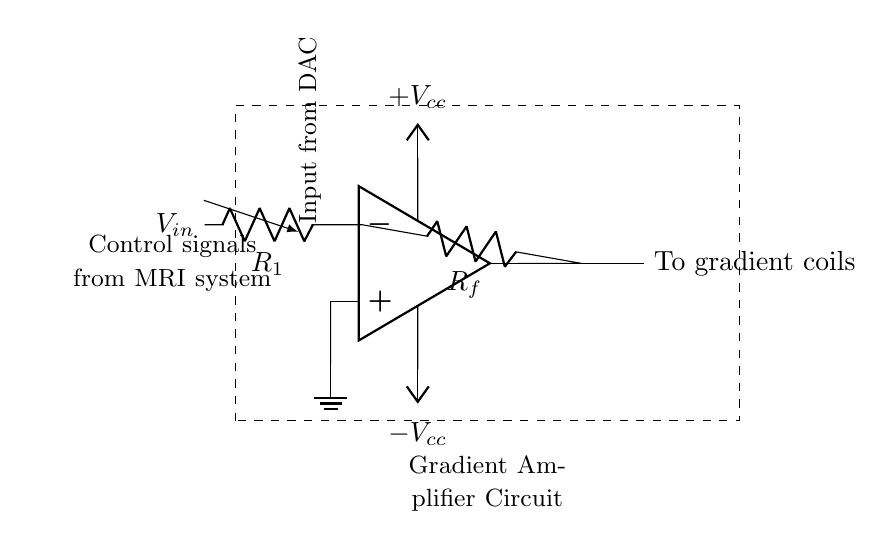What type of amplifier is used in the circuit? The circuit uses an operational amplifier, as indicated by the op amp symbol at the center of the diagram.
Answer: operational amplifier What components are connected to the inverting input of the op amp? The inverting input is connected to a resistor labeled R1 and the feedback resistor Rf, indicating the presence of feedback in the circuit.
Answer: R1 and Rf What is the role of the resistor labeled R_f? The feedback resistor Rf is used to set the gain of the op amp, affecting how much the output voltage will respond to the input voltage.
Answer: set the gain What is the power supply voltage for the op amp? The op amp is supplied with a positive voltage labeled as +V_cc and a negative voltage labeled as -V_cc, indicating a dual power supply configuration.
Answer: +V_cc and -V_cc What is the output of the circuit directed towards? The output of the op amp is directed towards the gradient coils, which are essential for creating the magnetic field gradients in an MRI machine.
Answer: gradient coils How does the feedback mechanism affect the circuit's operation? The feedback from R_f to the inverting input of the op amp ensures that the output voltage is controlled and stabilizes the circuit, preventing saturation and maintaining linear operation.
Answer: stabilizes the circuit Which component provides the input to the circuit? The input to the circuit is provided by a digital-to-analog converter (DAC), as labeled in the circuit diagram.
Answer: digital-to-analog converter (DAC) 